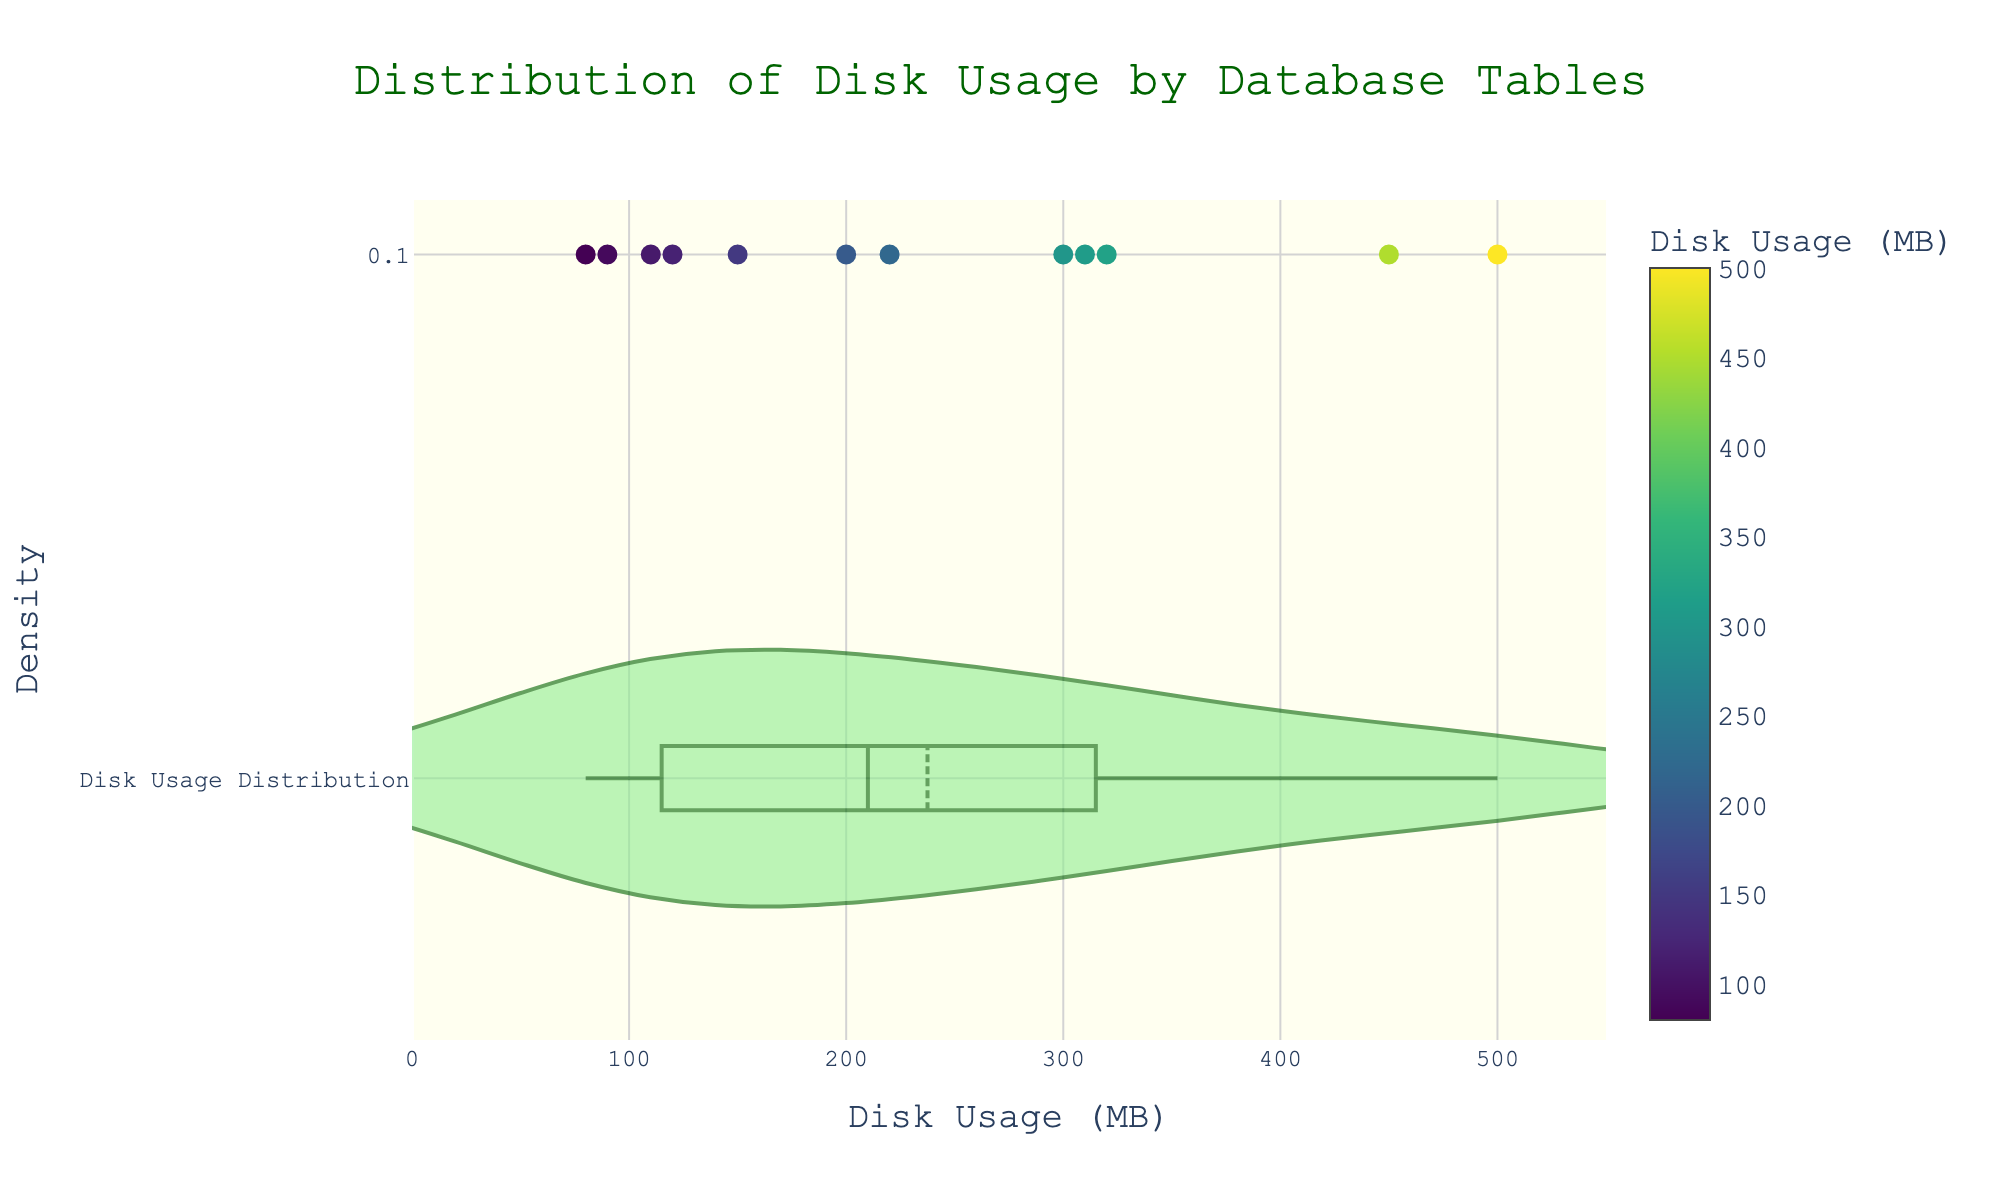What is the title of the density plot? The title is displayed at the top of the plot in large, bold text.
Answer: Distribution of Disk Usage by Database Tables How many tables are represented in the plot? Each scatter point corresponds to a table. Counting the points gives the total number of tables.
Answer: 12 Which table has the highest disk usage? Hovering over the scatter points and reading their values in the 'Disk Usage (MB)' color bar indicates the highest value.
Answer: Transactions What is the disk usage of the 'Employees' table? Hover over the point that represents 'Employees' or match it with its value from the scatter plot.
Answer: 90 MB Which table is closest to the average disk usage of all tables? Identify the mean line on the violin plot and hover over points closest to this line to compare their values.
Answer: Inventory or Financials What is the range of disk usage shown in the plot? The x-axis indicates the spread of values from the minimum to the maximum disk usage.
Answer: 80 MB to 500 MB How does the disk usage of 'Orders' compare to 'Products'? Locate the scatter points for 'Orders' and 'Products' and compare their x-values.
Answer: Orders uses more disk space than Products What is the median disk usage of the tables? The violin plot typically indicates the median line, displayed as the center line within the box plot elements of the violin.
Answer: Around 200 MB Which table has the second-highest disk usage? After identifying the highest disk usage, find the next highest from the scatter plot points.
Answer: Orders What is the disk usage value at the first quartile (Q1)? The violin plot's box shows quartiles; the left edge of the box inside the violin indicates Q1.
Answer: Around 120 MB 